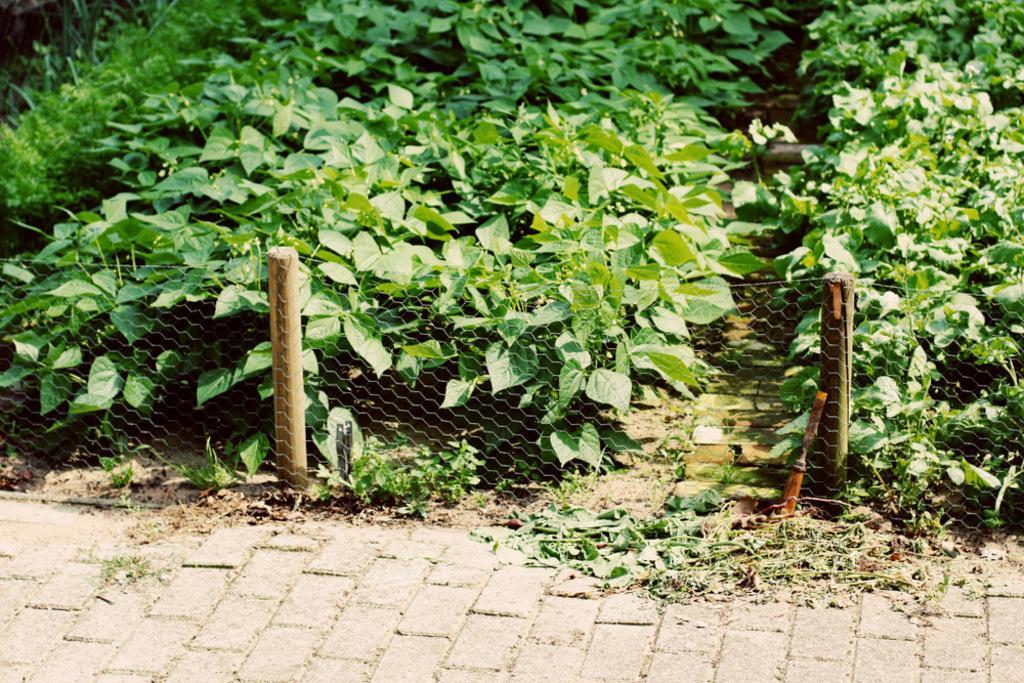Can you describe this image briefly? In this picture we can see fence and green plants. 